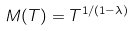<formula> <loc_0><loc_0><loc_500><loc_500>M ( T ) = T ^ { 1 / ( 1 - \lambda ) }</formula> 